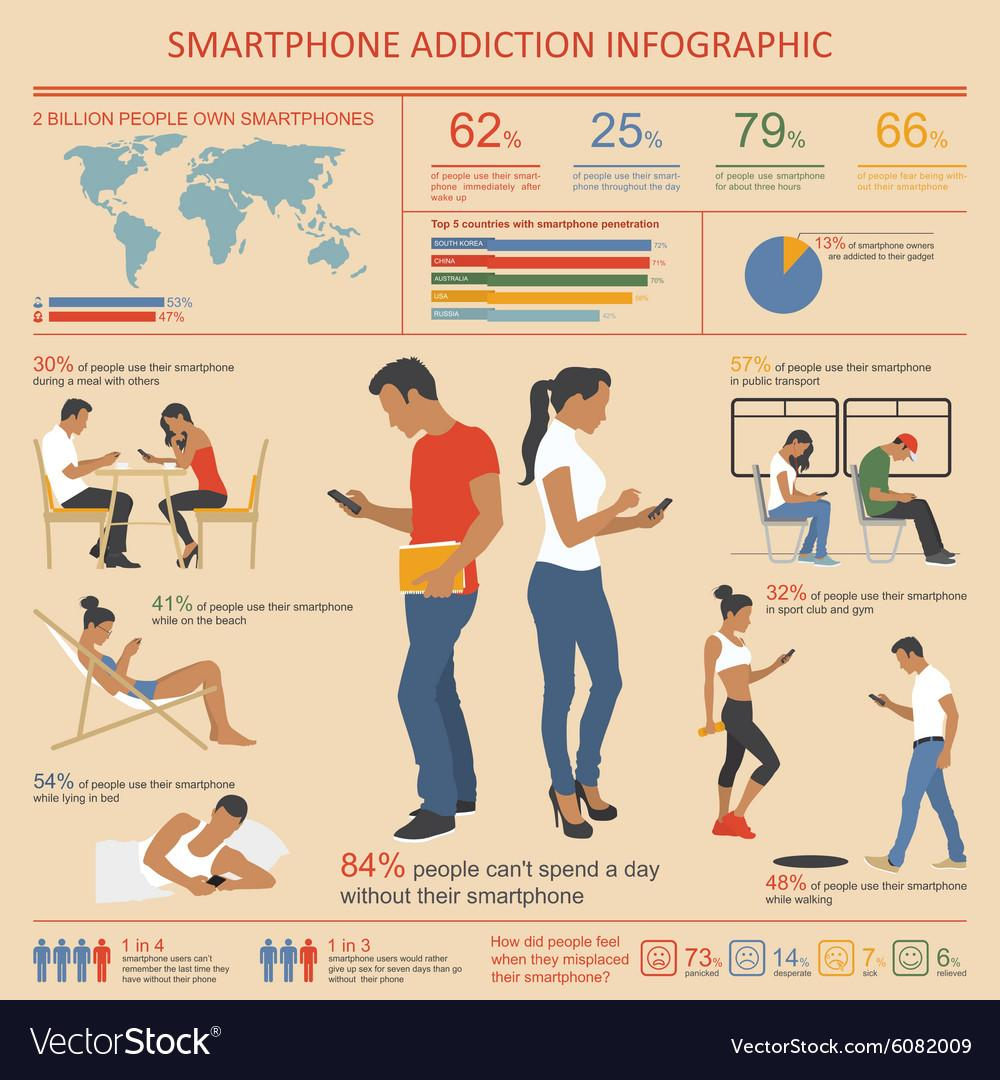Give some essential details in this illustration. According to a recent survey, it was found that 53% of males own smartphones. According to a survey, a large majority of smartphone owners, or 87%, are not addicted to their gadgets. According to a recent survey, 16% of people are able to spend an entire day without their smartphone. A recent survey found that 38% of people do not use their smartphones immediately after waking up. A recent survey has revealed that an overwhelming 66% of people fear being without their smartphone. 